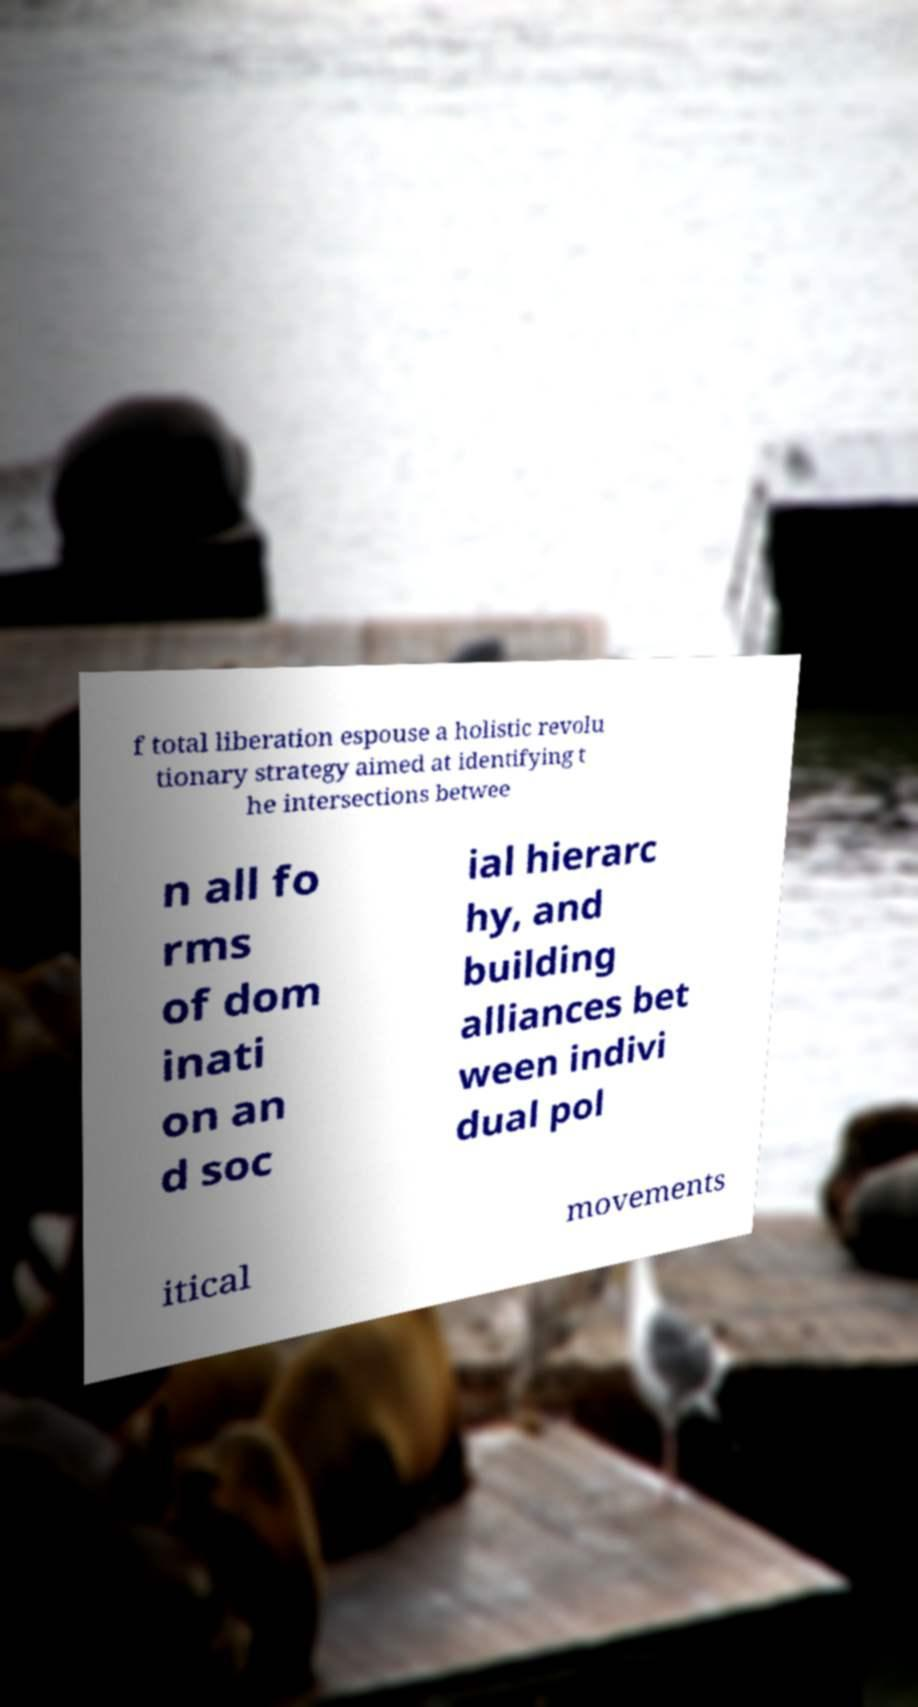Can you read and provide the text displayed in the image?This photo seems to have some interesting text. Can you extract and type it out for me? f total liberation espouse a holistic revolu tionary strategy aimed at identifying t he intersections betwee n all fo rms of dom inati on an d soc ial hierarc hy, and building alliances bet ween indivi dual pol itical movements 